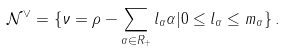<formula> <loc_0><loc_0><loc_500><loc_500>\mathcal { N } ^ { \vee } = \{ \nu = \rho - \sum _ { \alpha \in R _ { + } } l _ { \alpha } \alpha | 0 \leq l _ { \alpha } \leq m _ { \alpha } \} \, .</formula> 